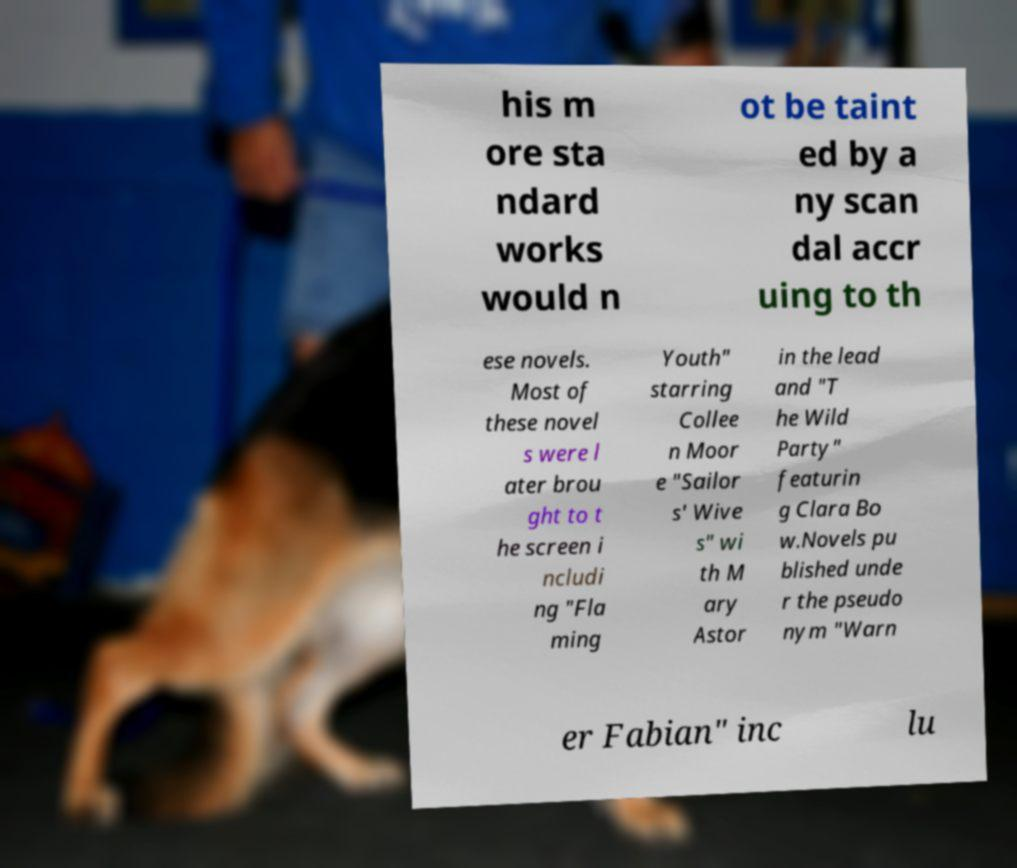Please identify and transcribe the text found in this image. his m ore sta ndard works would n ot be taint ed by a ny scan dal accr uing to th ese novels. Most of these novel s were l ater brou ght to t he screen i ncludi ng "Fla ming Youth" starring Collee n Moor e "Sailor s' Wive s" wi th M ary Astor in the lead and "T he Wild Party" featurin g Clara Bo w.Novels pu blished unde r the pseudo nym "Warn er Fabian" inc lu 